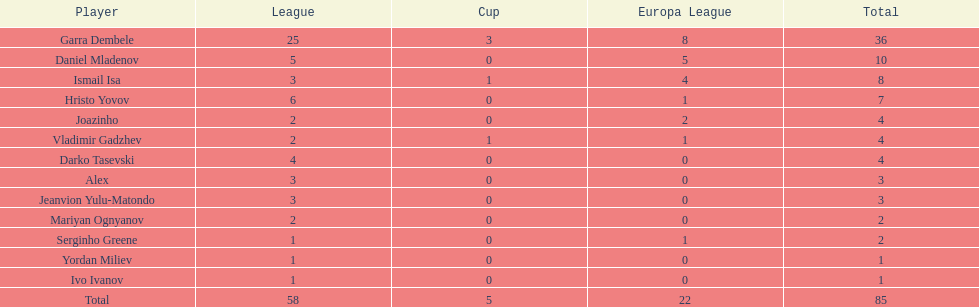What is the total sum of the cup and europa league amounts? 27. 